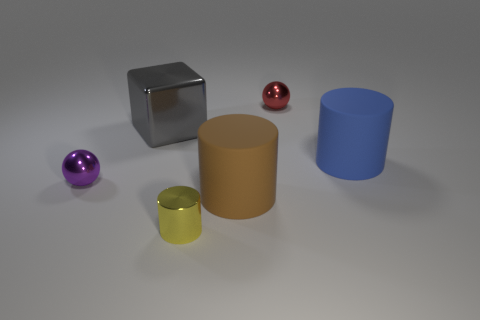What can we infer about the texture of the objects? We can infer that the objects vary in texture. The large grey cube and the tiny yellow cylinder have high specularity, indicating a smooth and polished surface, while the blue cylinder appears to have a matte finish with diffused reflections, suggesting a less smooth texture. 